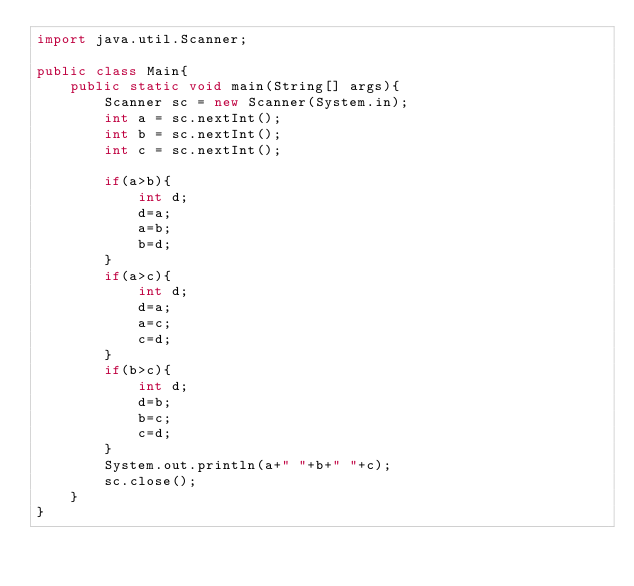<code> <loc_0><loc_0><loc_500><loc_500><_Java_>import java.util.Scanner;

public class Main{
    public static void main(String[] args){
        Scanner sc = new Scanner(System.in);
        int a = sc.nextInt();
        int b = sc.nextInt();
        int c = sc.nextInt();

        if(a>b){
            int d;
            d=a;
            a=b;
            b=d;
        }
        if(a>c){
            int d;
            d=a;
            a=c;
            c=d;
        }
        if(b>c){
            int d;
            d=b;
            b=c;
            c=d;
        }
        System.out.println(a+" "+b+" "+c);
        sc.close();
    }
}
</code> 